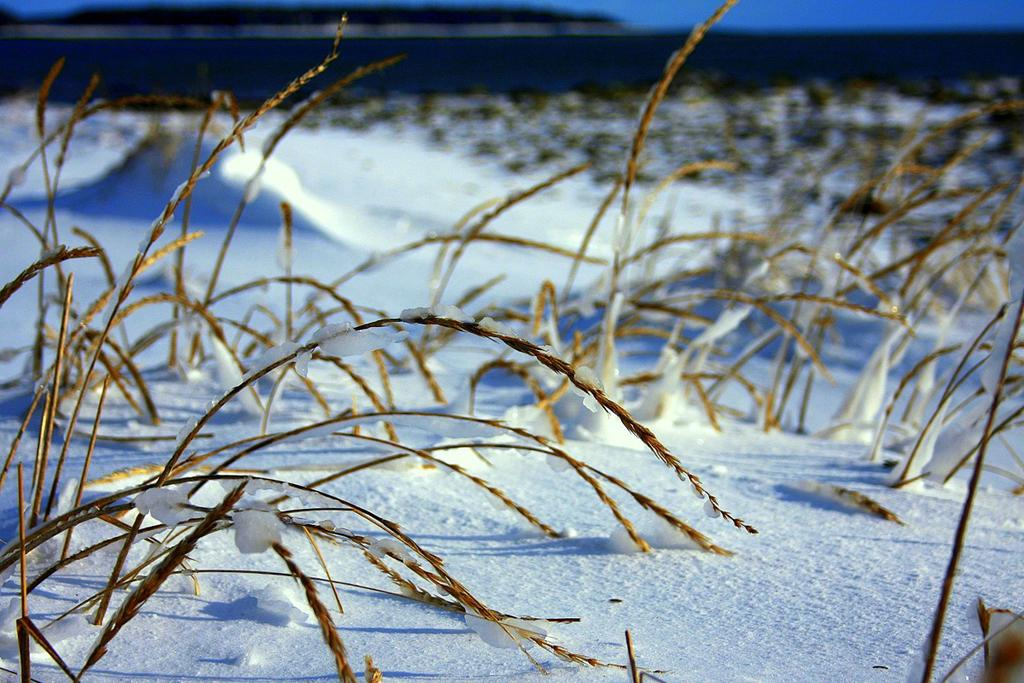What is the condition of the ground in the image? There is snow on the ground in the image. What type of vegetation can be seen in the image? There are brown color wheat plants in the image. What type of noise can be heard coming from the wheat plants in the image? There is no indication of any noise in the image, as it is a still photograph. Can you describe the home where the wheat plants are located in the image? There is no information about a home or any structure in the image; it only shows wheat plants and snow on the ground. 